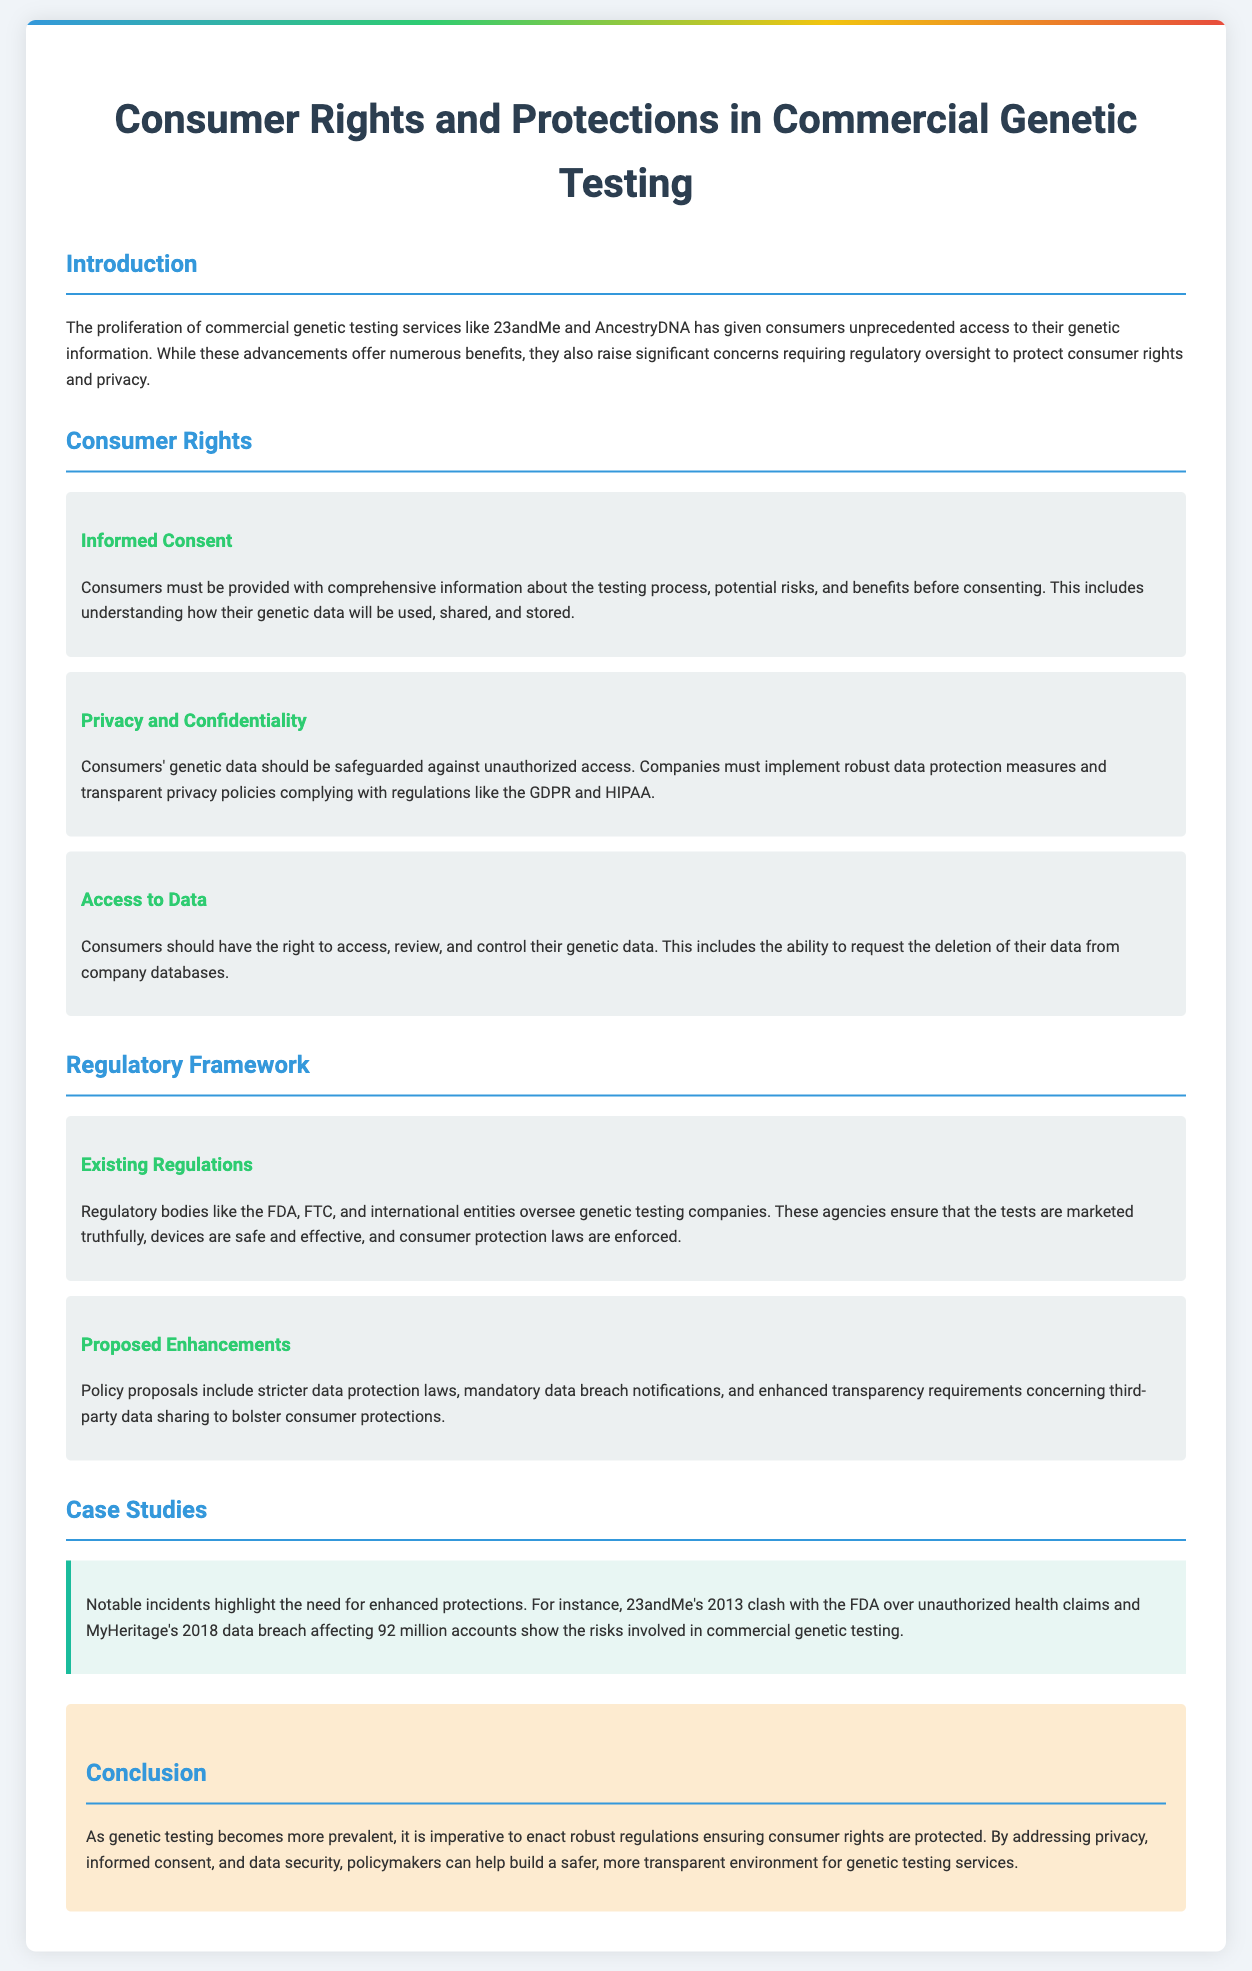what is the title of the document? The title is found in the first section of the document.
Answer: Consumer Rights and Protections in Commercial Genetic Testing what is one example of a commercial genetic testing service mentioned? The document lists specific companies in the introduction.
Answer: 23andMe what is a necessary requirement for consumers before genetic testing? This requirement is mentioned under the consumer rights section.
Answer: Informed Consent which regulatory body ensures that tests are marketed truthfully? The document refers to various regulatory bodies in the regulatory framework section.
Answer: FDA what was a consequence of the 2013 clash involving 23andMe? The document details significant incidents to highlight the need for protections.
Answer: Unauthorized health claims how many accounts were affected in the MyHeritage data breach? The document provides specific figures related to notable incidents.
Answer: 92 million what do proposed enhancements aim to increase in consumer protections? This is mentioned in the regulatory framework section discussing policy proposals.
Answer: Transparency requirements which act or regulation is mentioned in relation to data privacy? This information can be found in the privacy and confidentiality subsection.
Answer: GDPR what is emphasized as crucial in the conclusion? The conclusion summarizes the key focus areas for robust regulations.
Answer: Consumer rights 